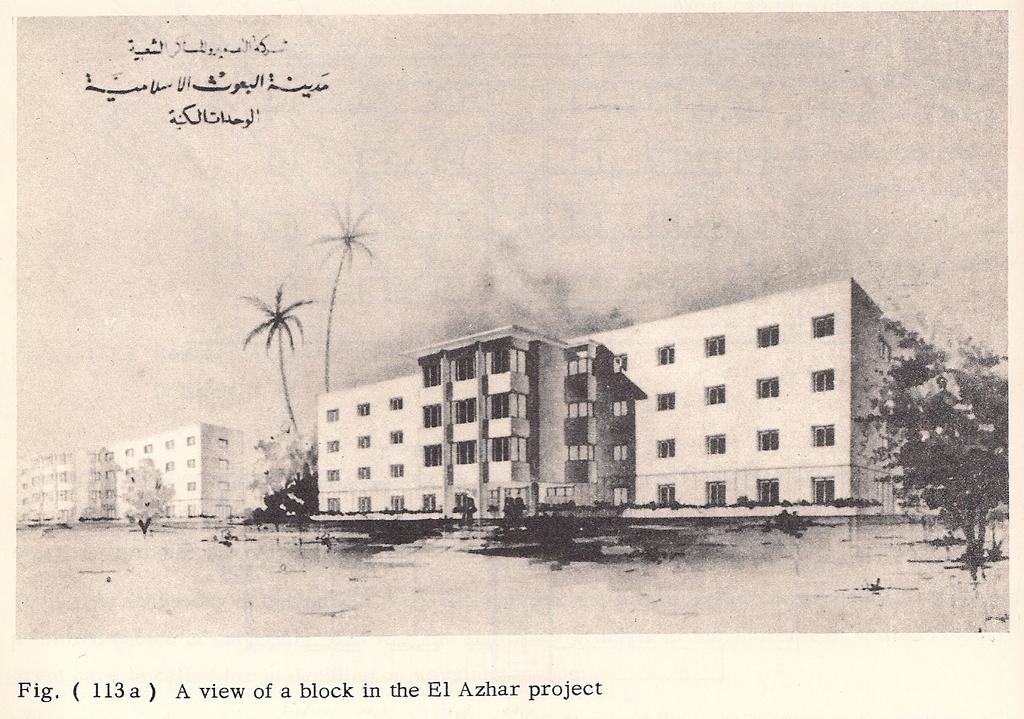What is the color scheme of the image? The image is black and white. What type of structures can be seen in the image? There are buildings in the image. What type of vegetation is present in the image? There are trees in the image. Is there any text present in the image? Yes, there is text on the image. Can you see a match and a flame in the image? There is no match or flame present in the image. What type of throat condition can be seen in the image? There is no throat condition present in the image, as it is a black and white image featuring buildings, trees, and text. 